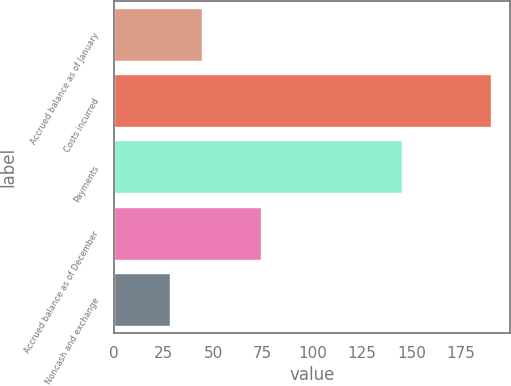Convert chart. <chart><loc_0><loc_0><loc_500><loc_500><bar_chart><fcel>Accrued balance as of January<fcel>Costs incurred<fcel>Payments<fcel>Accrued balance as of December<fcel>Noncash and exchange<nl><fcel>44.2<fcel>190<fcel>145<fcel>74<fcel>28<nl></chart> 